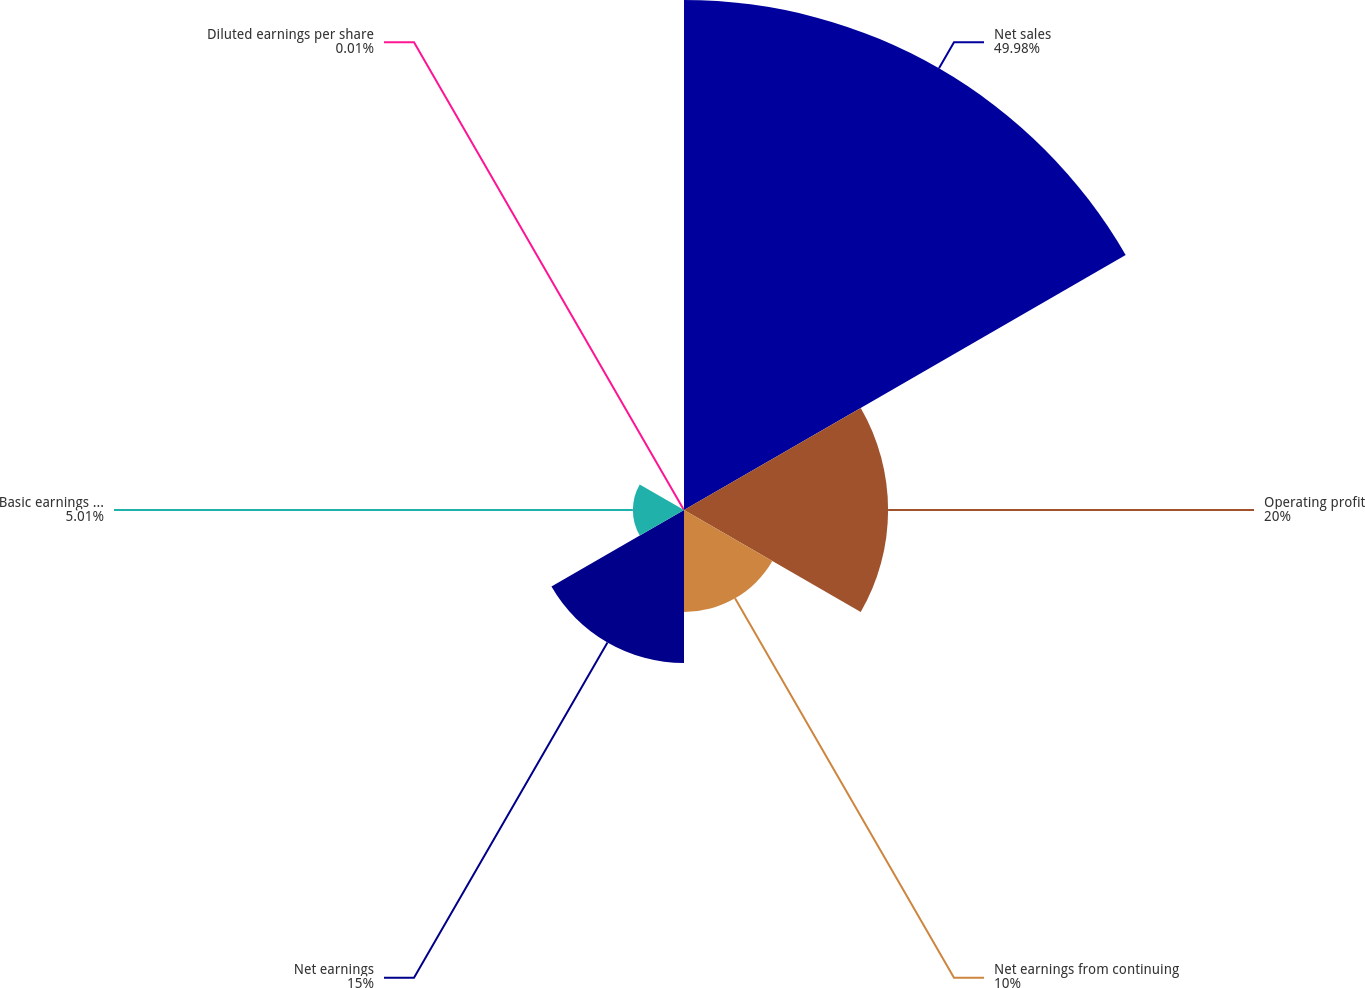Convert chart to OTSL. <chart><loc_0><loc_0><loc_500><loc_500><pie_chart><fcel>Net sales<fcel>Operating profit<fcel>Net earnings from continuing<fcel>Net earnings<fcel>Basic earnings per share (b)<fcel>Diluted earnings per share<nl><fcel>49.98%<fcel>20.0%<fcel>10.0%<fcel>15.0%<fcel>5.01%<fcel>0.01%<nl></chart> 